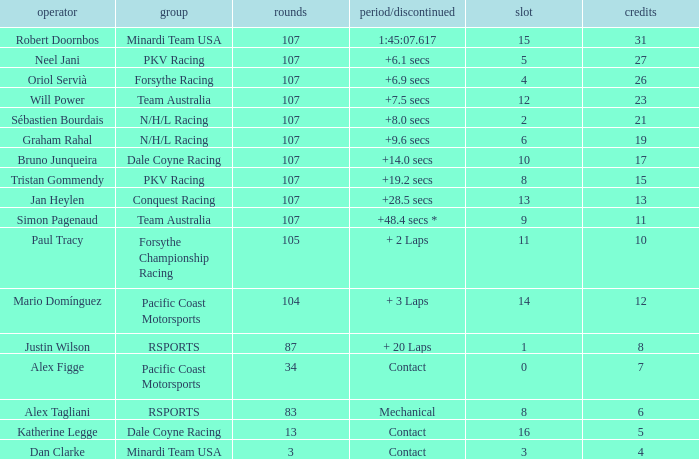What is mario domínguez's average Grid? 14.0. 